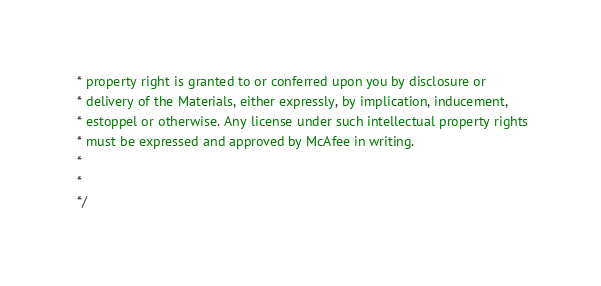Convert code to text. <code><loc_0><loc_0><loc_500><loc_500><_CSS_> * property right is granted to or conferred upon you by disclosure or
 * delivery of the Materials, either expressly, by implication, inducement,
 * estoppel or otherwise. Any license under such intellectual property rights
 * must be expressed and approved by McAfee in writing.
 * 
 * 
 */</code> 